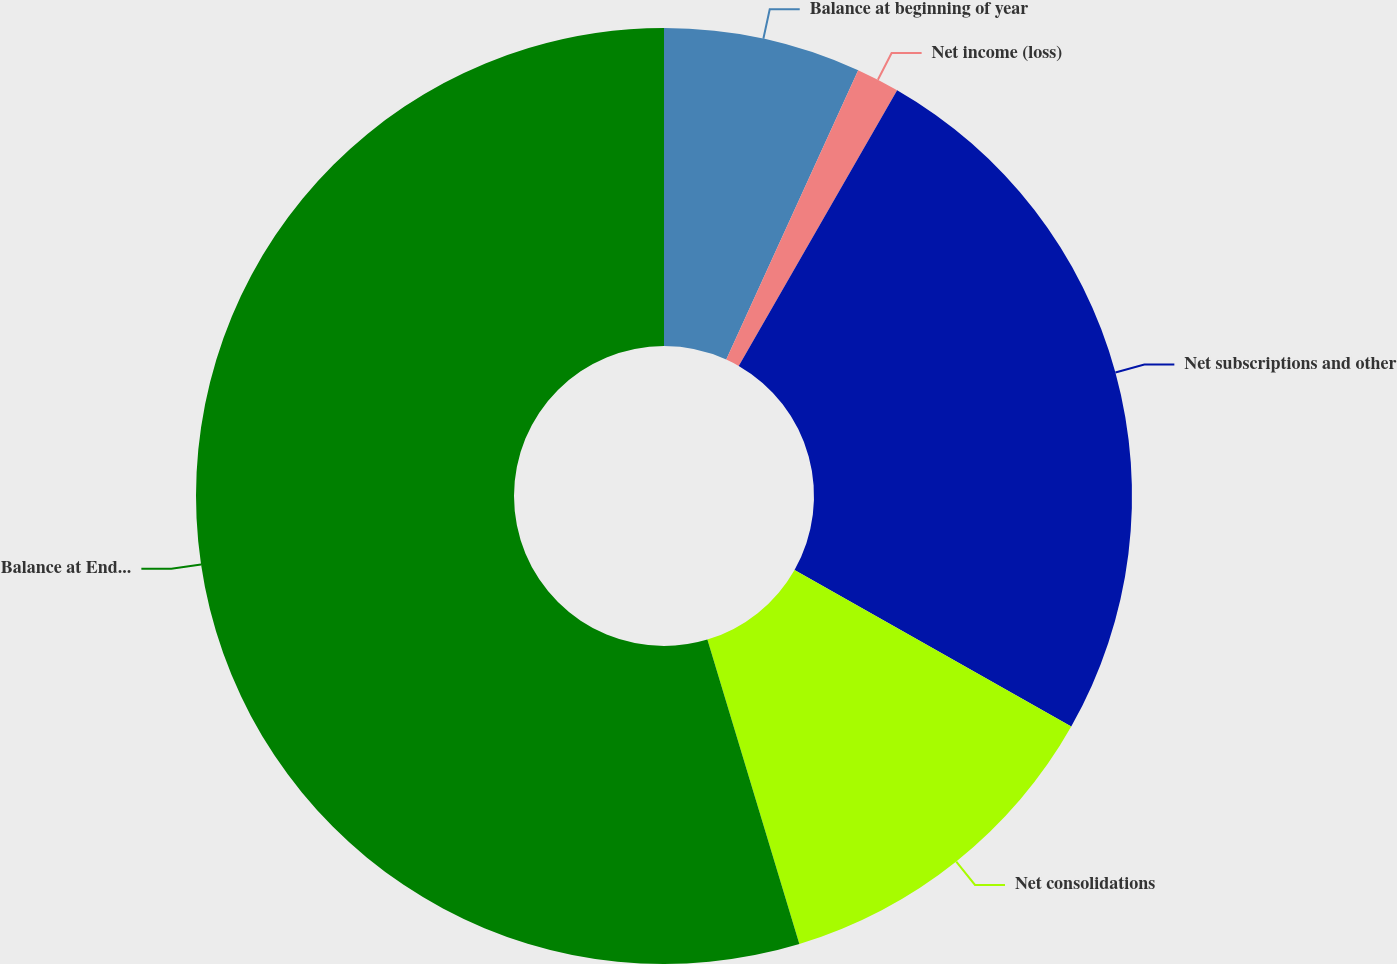<chart> <loc_0><loc_0><loc_500><loc_500><pie_chart><fcel>Balance at beginning of year<fcel>Net income (loss)<fcel>Net subscriptions and other<fcel>Net consolidations<fcel>Balance at End of Year<nl><fcel>6.81%<fcel>1.49%<fcel>24.9%<fcel>12.13%<fcel>54.67%<nl></chart> 